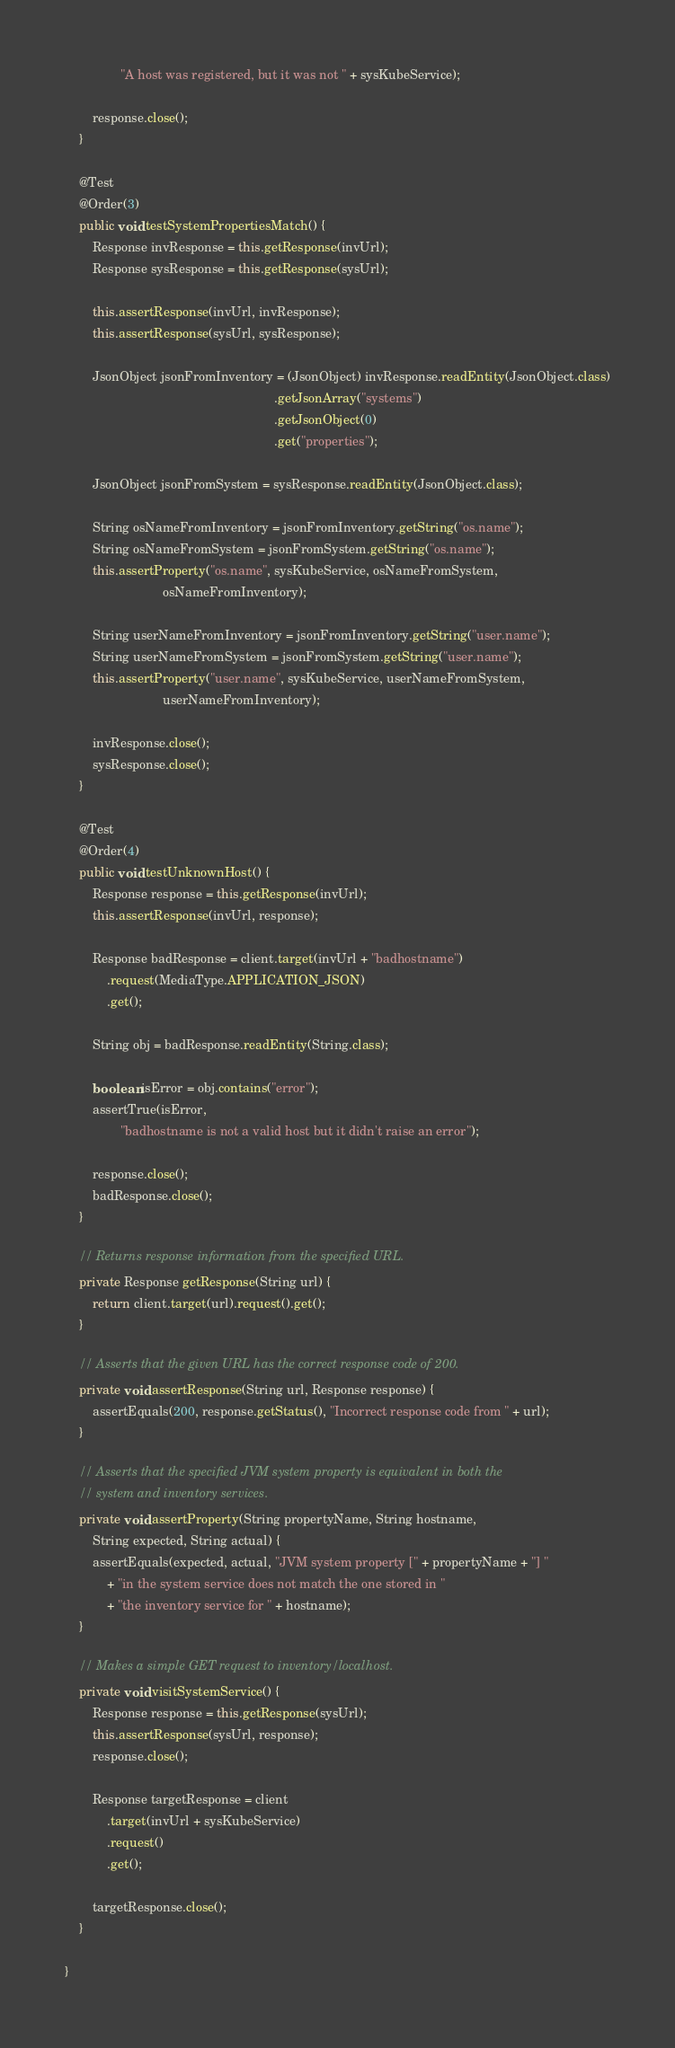Convert code to text. <code><loc_0><loc_0><loc_500><loc_500><_Java_>                "A host was registered, but it was not " + sysKubeService);

        response.close();
    }
    
    @Test
    @Order(3)
    public void testSystemPropertiesMatch() {
        Response invResponse = this.getResponse(invUrl);
        Response sysResponse = this.getResponse(sysUrl);

        this.assertResponse(invUrl, invResponse);
        this.assertResponse(sysUrl, sysResponse);

        JsonObject jsonFromInventory = (JsonObject) invResponse.readEntity(JsonObject.class)
                                                            .getJsonArray("systems")
                                                            .getJsonObject(0)
                                                            .get("properties");

        JsonObject jsonFromSystem = sysResponse.readEntity(JsonObject.class);

        String osNameFromInventory = jsonFromInventory.getString("os.name");
        String osNameFromSystem = jsonFromSystem.getString("os.name");
        this.assertProperty("os.name", sysKubeService, osNameFromSystem,
                            osNameFromInventory);

        String userNameFromInventory = jsonFromInventory.getString("user.name");
        String userNameFromSystem = jsonFromSystem.getString("user.name");
        this.assertProperty("user.name", sysKubeService, userNameFromSystem,
                            userNameFromInventory);

        invResponse.close();
        sysResponse.close();
    }
    
    @Test
    @Order(4)
    public void testUnknownHost() {
        Response response = this.getResponse(invUrl);
        this.assertResponse(invUrl, response);

        Response badResponse = client.target(invUrl + "badhostname")
            .request(MediaType.APPLICATION_JSON)
            .get();

        String obj = badResponse.readEntity(String.class);

        boolean isError = obj.contains("error");
        assertTrue(isError,
                "badhostname is not a valid host but it didn't raise an error");

        response.close();
        badResponse.close();
    }

    // Returns response information from the specified URL.
    private Response getResponse(String url) {
        return client.target(url).request().get();
    }

    // Asserts that the given URL has the correct response code of 200.
    private void assertResponse(String url, Response response) {
        assertEquals(200, response.getStatus(), "Incorrect response code from " + url);
    }

    // Asserts that the specified JVM system property is equivalent in both the
    // system and inventory services.
    private void assertProperty(String propertyName, String hostname,
        String expected, String actual) {
        assertEquals(expected, actual, "JVM system property [" + propertyName + "] "
            + "in the system service does not match the one stored in "
            + "the inventory service for " + hostname);
    }

    // Makes a simple GET request to inventory/localhost.
    private void visitSystemService() {
        Response response = this.getResponse(sysUrl);
        this.assertResponse(sysUrl, response);
        response.close();

        Response targetResponse = client
            .target(invUrl + sysKubeService)
            .request()
            .get();

        targetResponse.close();
    }

}
</code> 